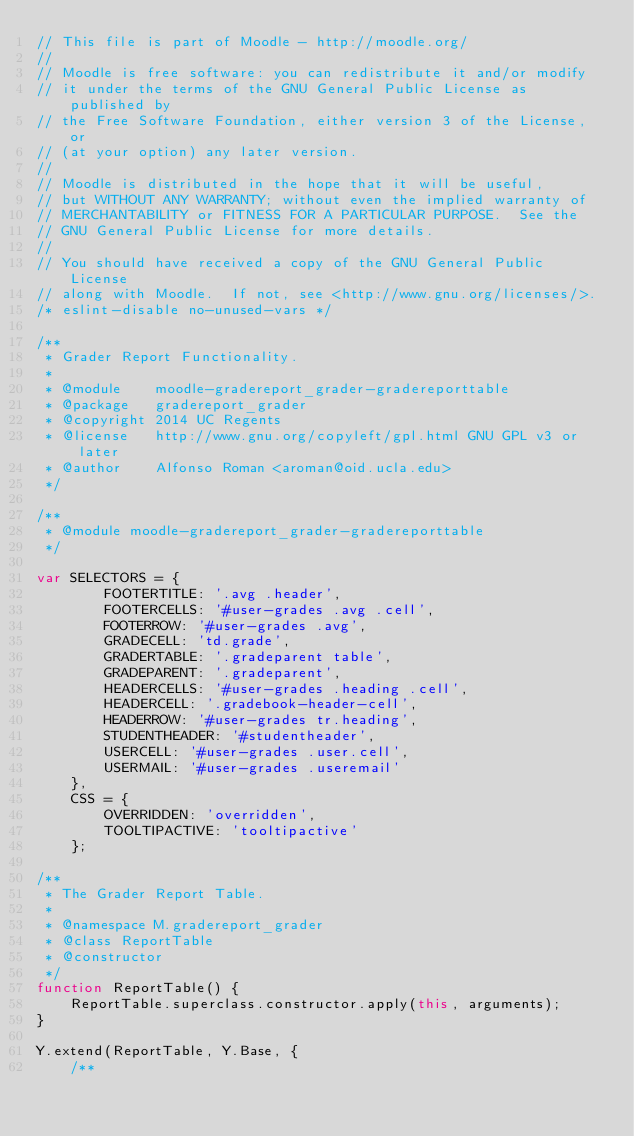Convert code to text. <code><loc_0><loc_0><loc_500><loc_500><_JavaScript_>// This file is part of Moodle - http://moodle.org/
//
// Moodle is free software: you can redistribute it and/or modify
// it under the terms of the GNU General Public License as published by
// the Free Software Foundation, either version 3 of the License, or
// (at your option) any later version.
//
// Moodle is distributed in the hope that it will be useful,
// but WITHOUT ANY WARRANTY; without even the implied warranty of
// MERCHANTABILITY or FITNESS FOR A PARTICULAR PURPOSE.  See the
// GNU General Public License for more details.
//
// You should have received a copy of the GNU General Public License
// along with Moodle.  If not, see <http://www.gnu.org/licenses/>.
/* eslint-disable no-unused-vars */

/**
 * Grader Report Functionality.
 *
 * @module    moodle-gradereport_grader-gradereporttable
 * @package   gradereport_grader
 * @copyright 2014 UC Regents
 * @license   http://www.gnu.org/copyleft/gpl.html GNU GPL v3 or later
 * @author    Alfonso Roman <aroman@oid.ucla.edu>
 */

/**
 * @module moodle-gradereport_grader-gradereporttable
 */

var SELECTORS = {
        FOOTERTITLE: '.avg .header',
        FOOTERCELLS: '#user-grades .avg .cell',
        FOOTERROW: '#user-grades .avg',
        GRADECELL: 'td.grade',
        GRADERTABLE: '.gradeparent table',
        GRADEPARENT: '.gradeparent',
        HEADERCELLS: '#user-grades .heading .cell',
        HEADERCELL: '.gradebook-header-cell',
        HEADERROW: '#user-grades tr.heading',
        STUDENTHEADER: '#studentheader',
        USERCELL: '#user-grades .user.cell',
        USERMAIL: '#user-grades .useremail'
    },
    CSS = {
        OVERRIDDEN: 'overridden',
        TOOLTIPACTIVE: 'tooltipactive'
    };

/**
 * The Grader Report Table.
 *
 * @namespace M.gradereport_grader
 * @class ReportTable
 * @constructor
 */
function ReportTable() {
    ReportTable.superclass.constructor.apply(this, arguments);
}

Y.extend(ReportTable, Y.Base, {
    /**</code> 